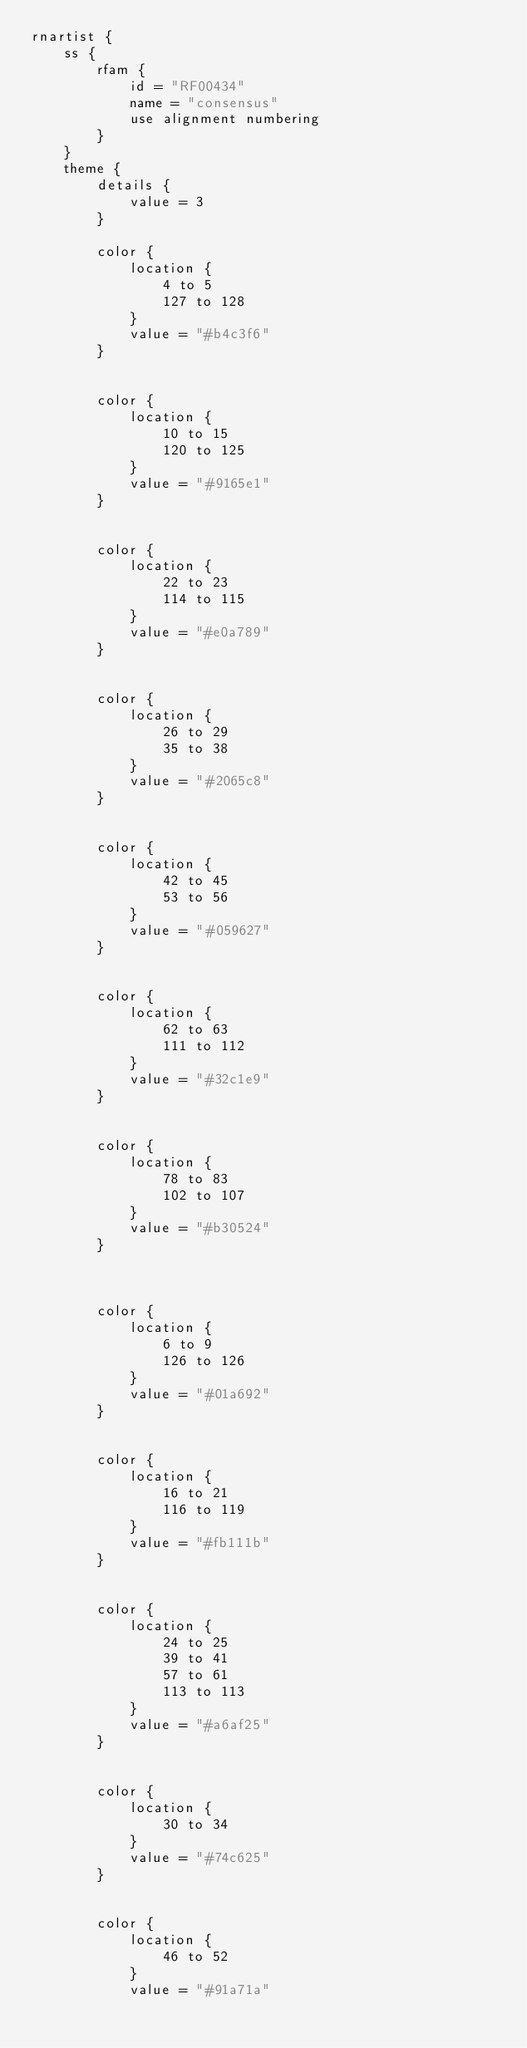Convert code to text. <code><loc_0><loc_0><loc_500><loc_500><_Kotlin_>rnartist {
    ss {
        rfam {
            id = "RF00434"
            name = "consensus"
            use alignment numbering
        }
    }
    theme {
        details { 
            value = 3
        }

        color {
            location {
                4 to 5
                127 to 128
            }
            value = "#b4c3f6"
        }


        color {
            location {
                10 to 15
                120 to 125
            }
            value = "#9165e1"
        }


        color {
            location {
                22 to 23
                114 to 115
            }
            value = "#e0a789"
        }


        color {
            location {
                26 to 29
                35 to 38
            }
            value = "#2065c8"
        }


        color {
            location {
                42 to 45
                53 to 56
            }
            value = "#059627"
        }


        color {
            location {
                62 to 63
                111 to 112
            }
            value = "#32c1e9"
        }


        color {
            location {
                78 to 83
                102 to 107
            }
            value = "#b30524"
        }



        color {
            location {
                6 to 9
                126 to 126
            }
            value = "#01a692"
        }


        color {
            location {
                16 to 21
                116 to 119
            }
            value = "#fb111b"
        }


        color {
            location {
                24 to 25
                39 to 41
                57 to 61
                113 to 113
            }
            value = "#a6af25"
        }


        color {
            location {
                30 to 34
            }
            value = "#74c625"
        }


        color {
            location {
                46 to 52
            }
            value = "#91a71a"</code> 